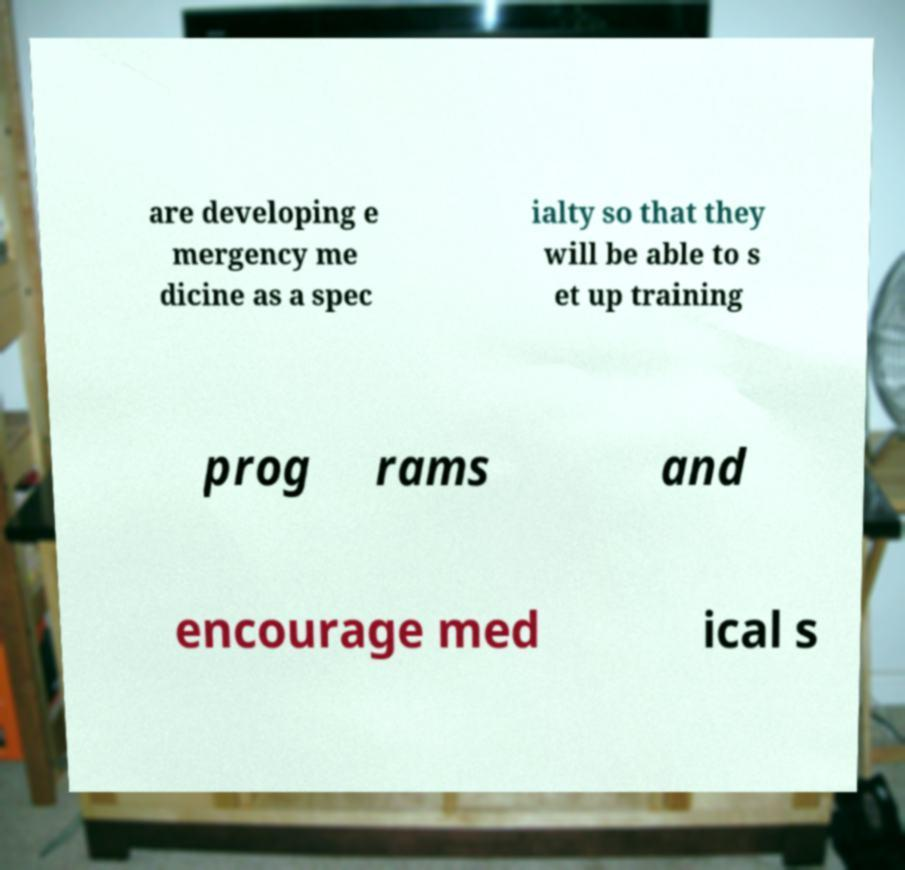There's text embedded in this image that I need extracted. Can you transcribe it verbatim? are developing e mergency me dicine as a spec ialty so that they will be able to s et up training prog rams and encourage med ical s 